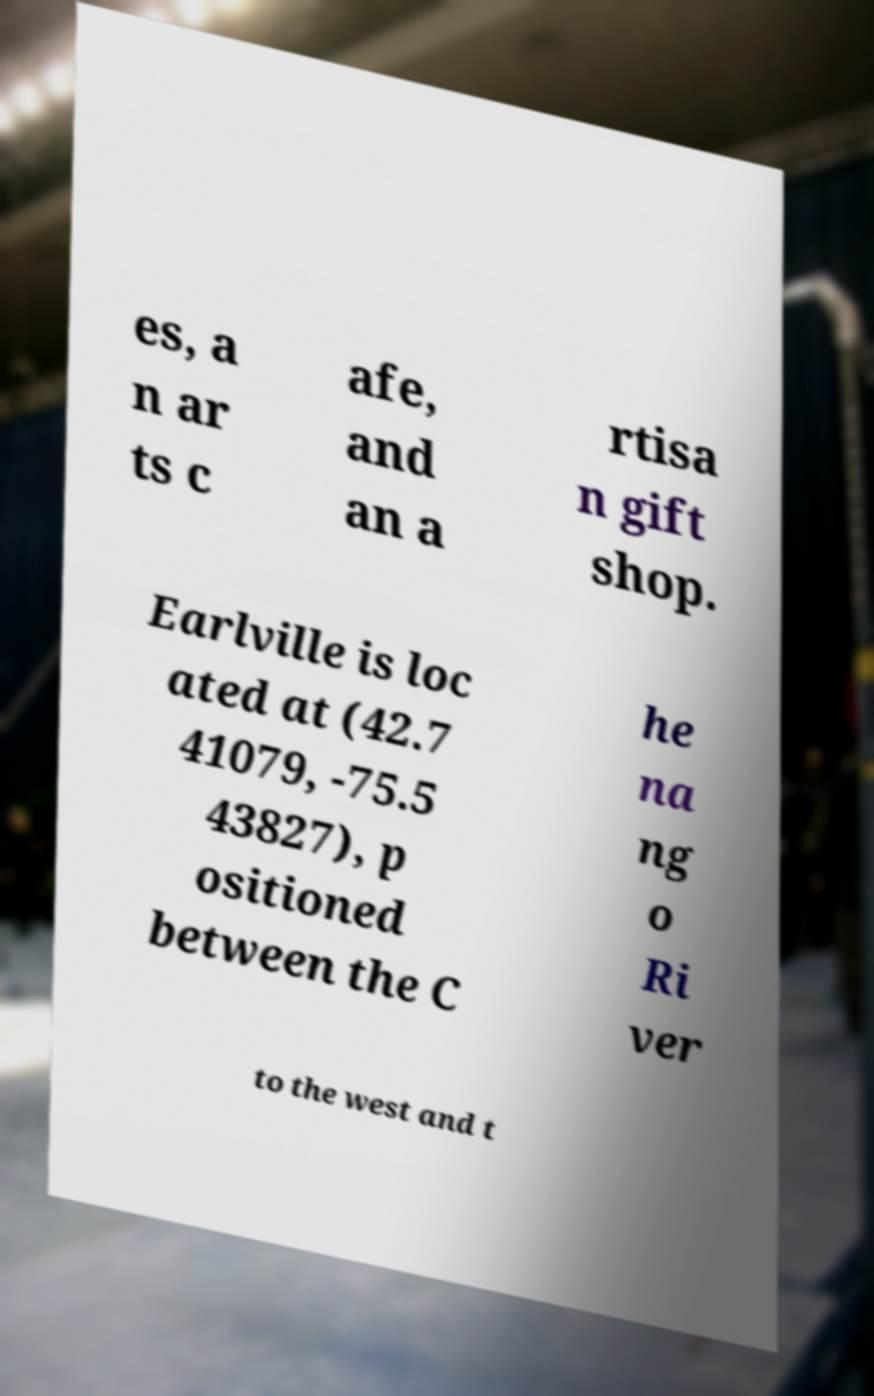For documentation purposes, I need the text within this image transcribed. Could you provide that? es, a n ar ts c afe, and an a rtisa n gift shop. Earlville is loc ated at (42.7 41079, -75.5 43827), p ositioned between the C he na ng o Ri ver to the west and t 